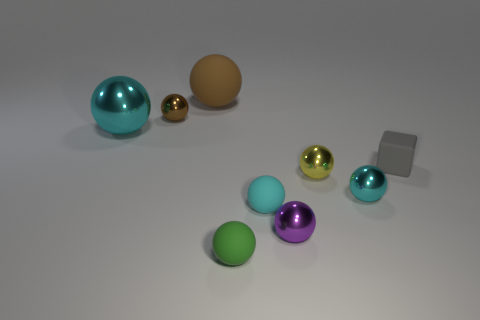What color is the matte thing that is behind the gray object?
Offer a very short reply. Brown. How big is the rubber thing that is both to the right of the green sphere and left of the cube?
Offer a terse response. Small. Do the block and the brown sphere to the left of the large brown object have the same material?
Keep it short and to the point. No. How many green things have the same shape as the big brown rubber object?
Provide a succinct answer. 1. There is a small sphere that is the same color as the big matte object; what is its material?
Make the answer very short. Metal. What number of small blue metallic objects are there?
Your answer should be very brief. 0. Does the tiny green matte thing have the same shape as the small cyan object that is on the left side of the yellow ball?
Provide a short and direct response. Yes. How many objects are either tiny gray metal things or cyan objects that are to the left of the small purple metallic sphere?
Your response must be concise. 2. There is a large brown thing that is the same shape as the tiny green thing; what is it made of?
Offer a very short reply. Rubber. There is a tiny cyan thing behind the small cyan rubber ball; is it the same shape as the tiny purple object?
Make the answer very short. Yes. 